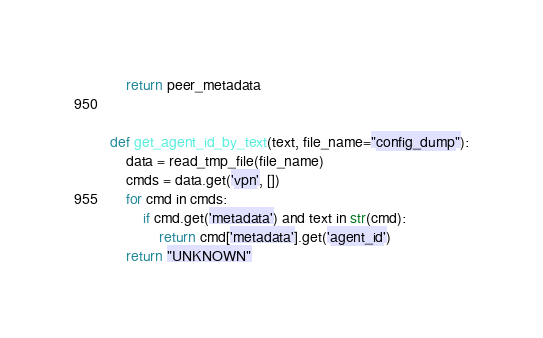Convert code to text. <code><loc_0><loc_0><loc_500><loc_500><_Python_>    return peer_metadata


def get_agent_id_by_text(text, file_name="config_dump"):
    data = read_tmp_file(file_name)
    cmds = data.get('vpn', [])
    for cmd in cmds:
        if cmd.get('metadata') and text in str(cmd):
            return cmd['metadata'].get('agent_id')
    return "UNKNOWN"
</code> 